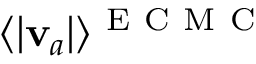Convert formula to latex. <formula><loc_0><loc_0><loc_500><loc_500>\langle | v _ { a } | \rangle ^ { E C M C }</formula> 